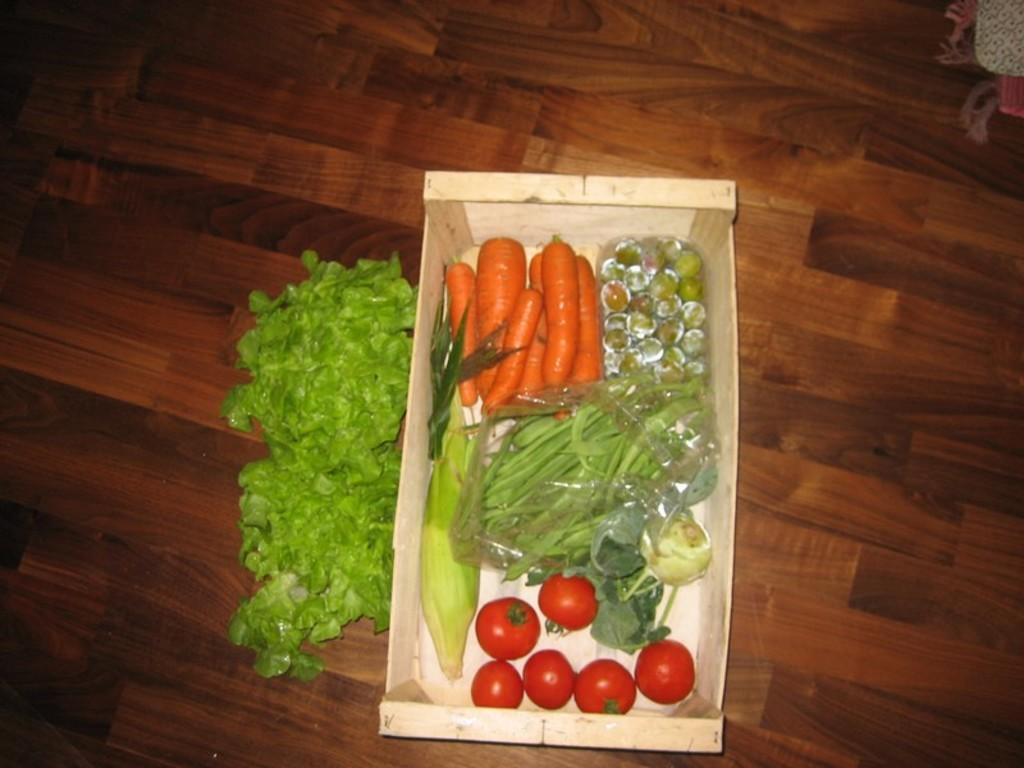What type of food is visible in the image? There are vegetables in the image. Where are the vegetables located in the image? The vegetables are in the center of the image. What type of playground equipment can be seen in the image? There is no playground equipment present in the image; it features vegetables in the center. 